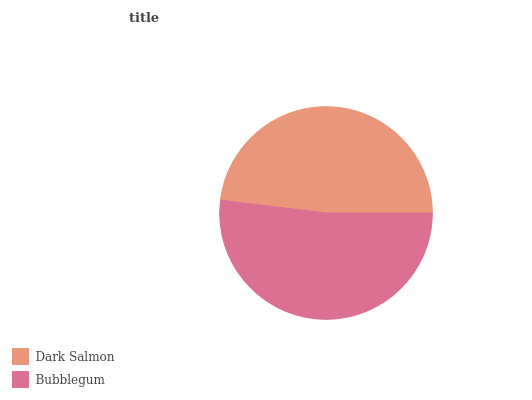Is Dark Salmon the minimum?
Answer yes or no. Yes. Is Bubblegum the maximum?
Answer yes or no. Yes. Is Bubblegum the minimum?
Answer yes or no. No. Is Bubblegum greater than Dark Salmon?
Answer yes or no. Yes. Is Dark Salmon less than Bubblegum?
Answer yes or no. Yes. Is Dark Salmon greater than Bubblegum?
Answer yes or no. No. Is Bubblegum less than Dark Salmon?
Answer yes or no. No. Is Bubblegum the high median?
Answer yes or no. Yes. Is Dark Salmon the low median?
Answer yes or no. Yes. Is Dark Salmon the high median?
Answer yes or no. No. Is Bubblegum the low median?
Answer yes or no. No. 